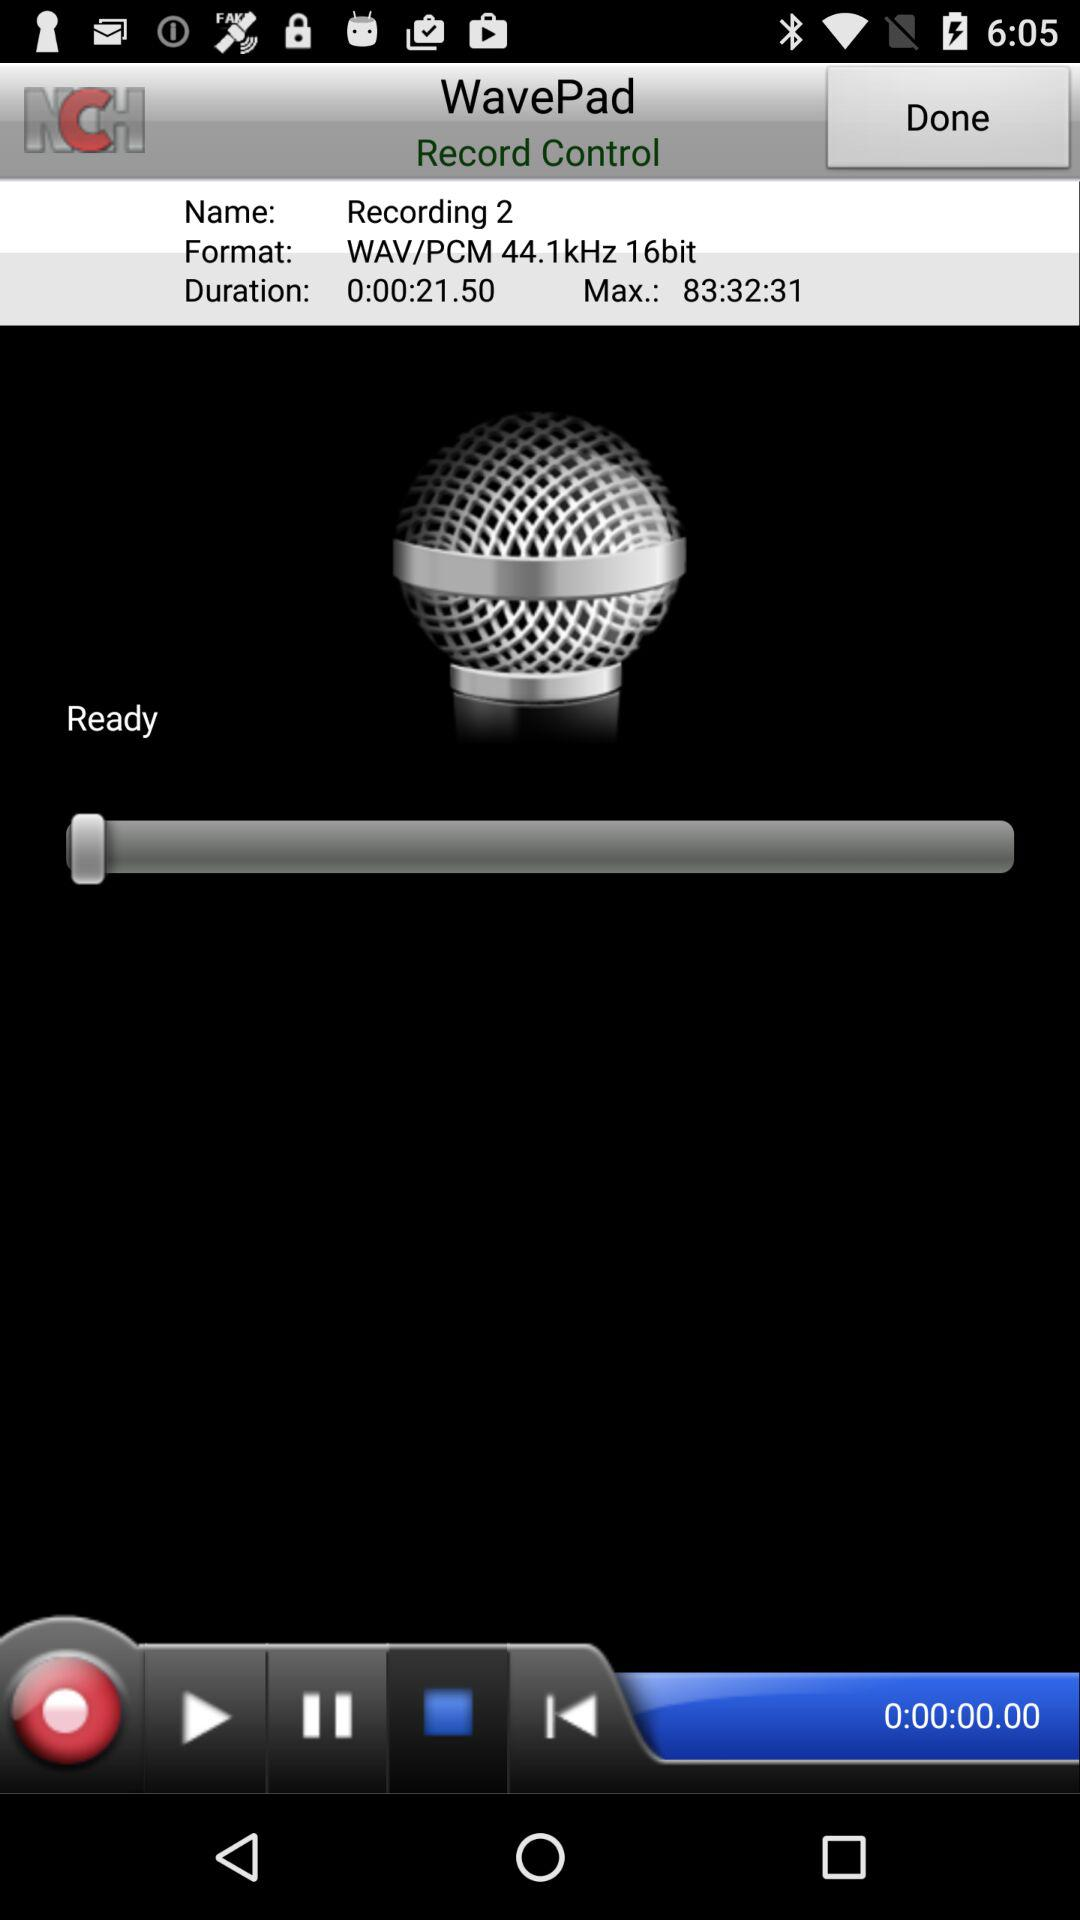What is the name? The name is "Recording 2". 